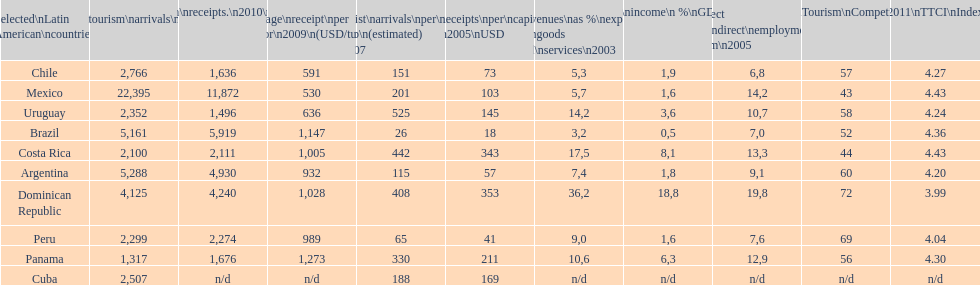What is the last country listed on this chart? Uruguay. 